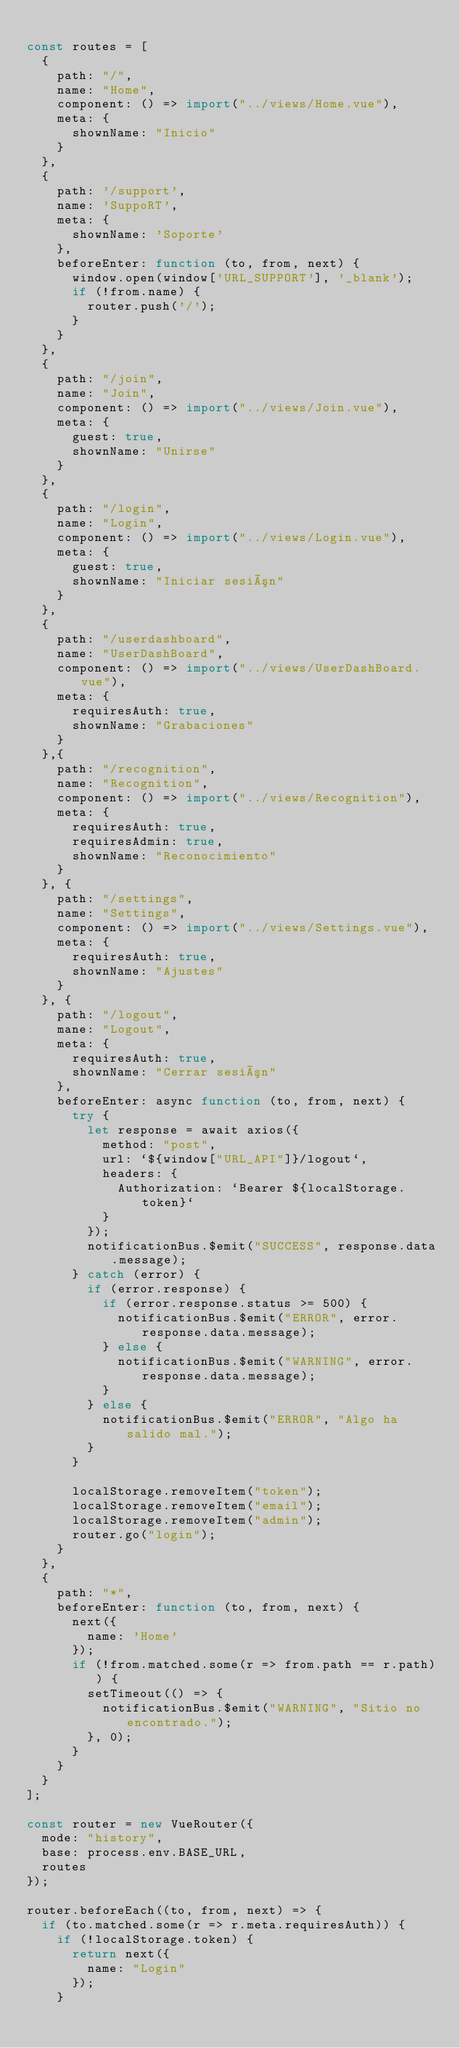<code> <loc_0><loc_0><loc_500><loc_500><_JavaScript_>
const routes = [
  {
    path: "/",
    name: "Home",
    component: () => import("../views/Home.vue"),
    meta: {
      shownName: "Inicio"
    }
  },
  {
    path: '/support',
    name: 'SuppoRT',
    meta: {
      shownName: 'Soporte'
    },
    beforeEnter: function (to, from, next) {
      window.open(window['URL_SUPPORT'], '_blank');
      if (!from.name) {
        router.push('/');
      }
    }
  },
  {
    path: "/join",
    name: "Join",
    component: () => import("../views/Join.vue"),
    meta: {
      guest: true,
      shownName: "Unirse"
    }
  },
  {
    path: "/login",
    name: "Login",
    component: () => import("../views/Login.vue"),
    meta: {
      guest: true,
      shownName: "Iniciar sesión"
    }
  },
  {
    path: "/userdashboard",
    name: "UserDashBoard",
    component: () => import("../views/UserDashBoard.vue"),
    meta: {
      requiresAuth: true,
      shownName: "Grabaciones"
    }
  },{
    path: "/recognition",
    name: "Recognition",
    component: () => import("../views/Recognition"),
    meta: {
      requiresAuth: true,
      requiresAdmin: true,
      shownName: "Reconocimiento"
    }
  }, {
    path: "/settings",
    name: "Settings",
    component: () => import("../views/Settings.vue"),
    meta: {
      requiresAuth: true,
      shownName: "Ajustes"
    }
  }, {
    path: "/logout",
    mane: "Logout",
    meta: {
      requiresAuth: true,
      shownName: "Cerrar sesión"
    },
    beforeEnter: async function (to, from, next) {
      try {
        let response = await axios({
          method: "post",
          url: `${window["URL_API"]}/logout`,
          headers: {
            Authorization: `Bearer ${localStorage.token}`
          }
        });
        notificationBus.$emit("SUCCESS", response.data.message);
      } catch (error) {
        if (error.response) {
          if (error.response.status >= 500) {
            notificationBus.$emit("ERROR", error.response.data.message);
          } else {
            notificationBus.$emit("WARNING", error.response.data.message);
          }
        } else {
          notificationBus.$emit("ERROR", "Algo ha salido mal.");
        }
      }

      localStorage.removeItem("token");
      localStorage.removeItem("email");
      localStorage.removeItem("admin");
      router.go("login");
    }
  },
  {
    path: "*",
    beforeEnter: function (to, from, next) {
      next({
        name: 'Home'
      });
      if (!from.matched.some(r => from.path == r.path)) {
        setTimeout(() => {
          notificationBus.$emit("WARNING", "Sitio no encontrado.");
        }, 0);
      }
    }
  }
];

const router = new VueRouter({
  mode: "history",
  base: process.env.BASE_URL,
  routes
});

router.beforeEach((to, from, next) => {
  if (to.matched.some(r => r.meta.requiresAuth)) {
    if (!localStorage.token) {
      return next({
        name: "Login"
      });
    }</code> 